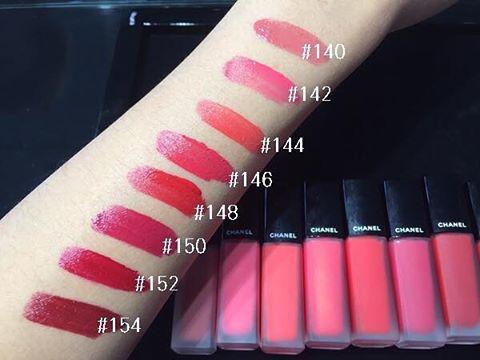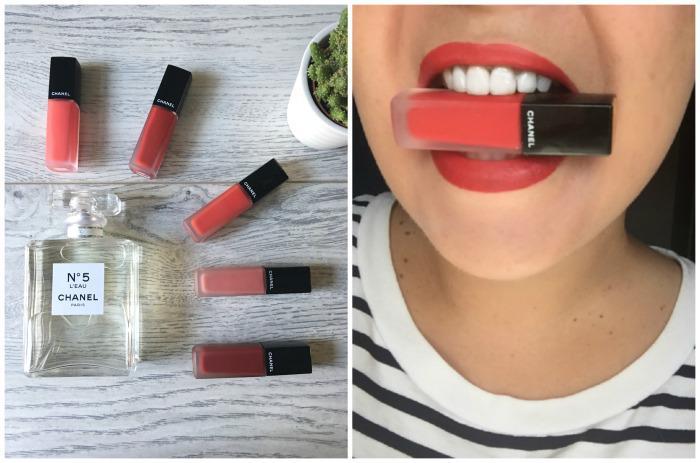The first image is the image on the left, the second image is the image on the right. Considering the images on both sides, is "Tinted lips and smears of different lipstick colors are shown, along with containers of lip makeup." valid? Answer yes or no. Yes. The first image is the image on the left, the second image is the image on the right. Evaluate the accuracy of this statement regarding the images: "A woman's teeth are visible in one of the images.". Is it true? Answer yes or no. Yes. 